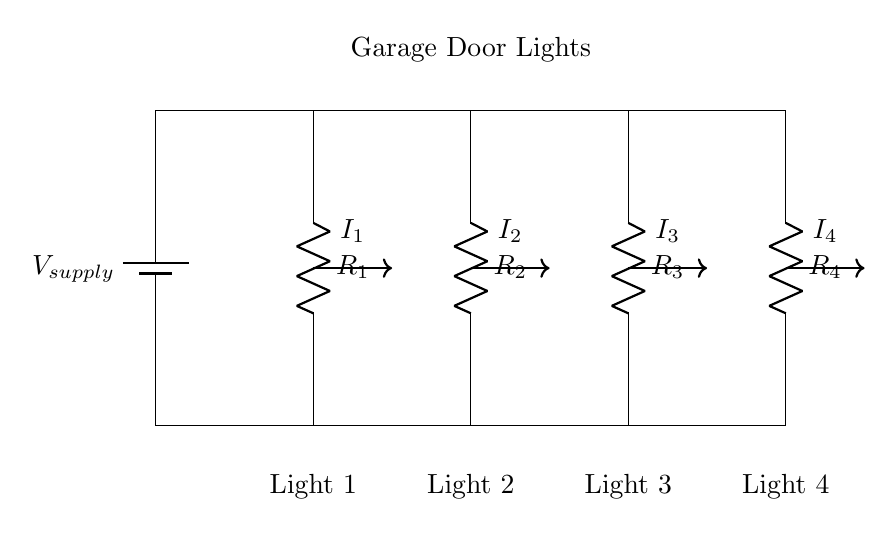What is the supply voltage in this circuit? The supply voltage is indicated as V supply, which represents the voltage source that powers the circuit.
Answer: V supply How many lights are connected in parallel? There are four resistors labeled as R1, R2, R3, and R4, corresponding to four lights in parallel.
Answer: Four What type of circuit is this? This is a parallel circuit, as the components are connected across the same two nodes, allowing for multiple paths for current.
Answer: Parallel Which resistor is connected to light 3? Light 3 is connected to resistor R3 in the circuit, as indicated by its position in the parallel configuration.
Answer: R3 How does the current divide among the lights? The current is divided according to the resistance of each light, with lower resistance receiving a higher current, following the current divider rule.
Answer: According to resistance What is the relationship between total current and individual currents in a parallel circuit? The total current entering the parallel circuit equals the sum of the individual currents through each resistor, I total = I1 + I2 + I3 + I4.
Answer: Total current equals the sum of individual currents 